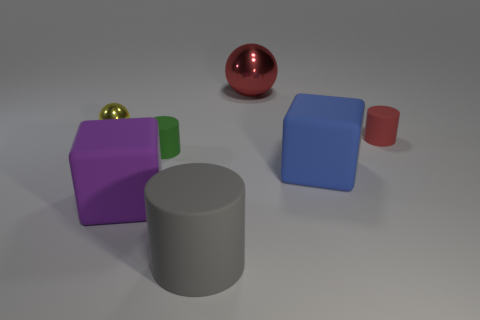Are there an equal number of small red cylinders in front of the tiny yellow object and shiny objects to the left of the large red object?
Give a very brief answer. Yes. There is a rubber cube that is right of the big block left of the shiny ball that is to the right of the green matte cylinder; what color is it?
Make the answer very short. Blue. Is there any other thing that has the same color as the big shiny object?
Give a very brief answer. Yes. There is a ball to the left of the small green matte object; what size is it?
Offer a very short reply. Small. The purple thing that is the same size as the gray matte cylinder is what shape?
Your answer should be very brief. Cube. Do the tiny object that is in front of the tiny red cylinder and the cylinder that is in front of the purple object have the same material?
Your response must be concise. Yes. The tiny green cylinder that is to the left of the red thing behind the small yellow sphere is made of what material?
Ensure brevity in your answer.  Rubber. What size is the rubber cylinder that is to the right of the big matte block to the right of the big matte object on the left side of the tiny green matte thing?
Your answer should be compact. Small. Do the red shiny ball and the green rubber cylinder have the same size?
Your answer should be compact. No. There is a red object to the left of the blue thing; is it the same shape as the red object that is in front of the tiny yellow thing?
Your response must be concise. No. 